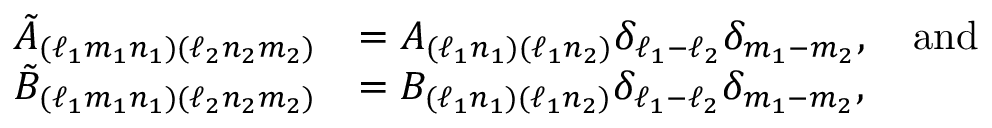Convert formula to latex. <formula><loc_0><loc_0><loc_500><loc_500>\begin{array} { r l } { \tilde { A } _ { ( \ell _ { 1 } m _ { 1 } n _ { 1 } ) ( \ell _ { 2 } n _ { 2 } m _ { 2 } ) } } & { = A _ { ( \ell _ { 1 } n _ { 1 } ) ( \ell _ { 1 } n _ { 2 } ) } \delta _ { \ell _ { 1 } - \ell _ { 2 } } \delta _ { m _ { 1 } - m _ { 2 } } , \quad a n d } \\ { \tilde { B } _ { ( \ell _ { 1 } m _ { 1 } n _ { 1 } ) ( \ell _ { 2 } n _ { 2 } m _ { 2 } ) } } & { = B _ { ( \ell _ { 1 } n _ { 1 } ) ( \ell _ { 1 } n _ { 2 } ) } \delta _ { \ell _ { 1 } - \ell _ { 2 } } \delta _ { m _ { 1 } - m _ { 2 } } , } \end{array}</formula> 